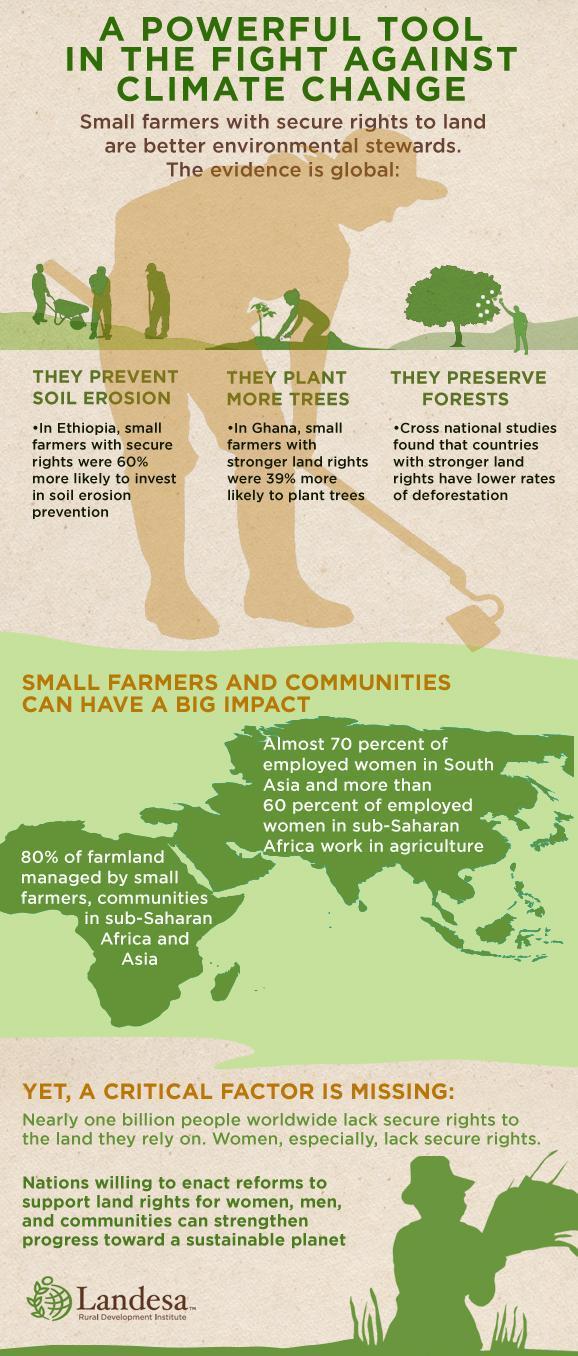Which continents did most small farmer communities belong to ?
Answer the question with a short phrase. Africa, Asia 